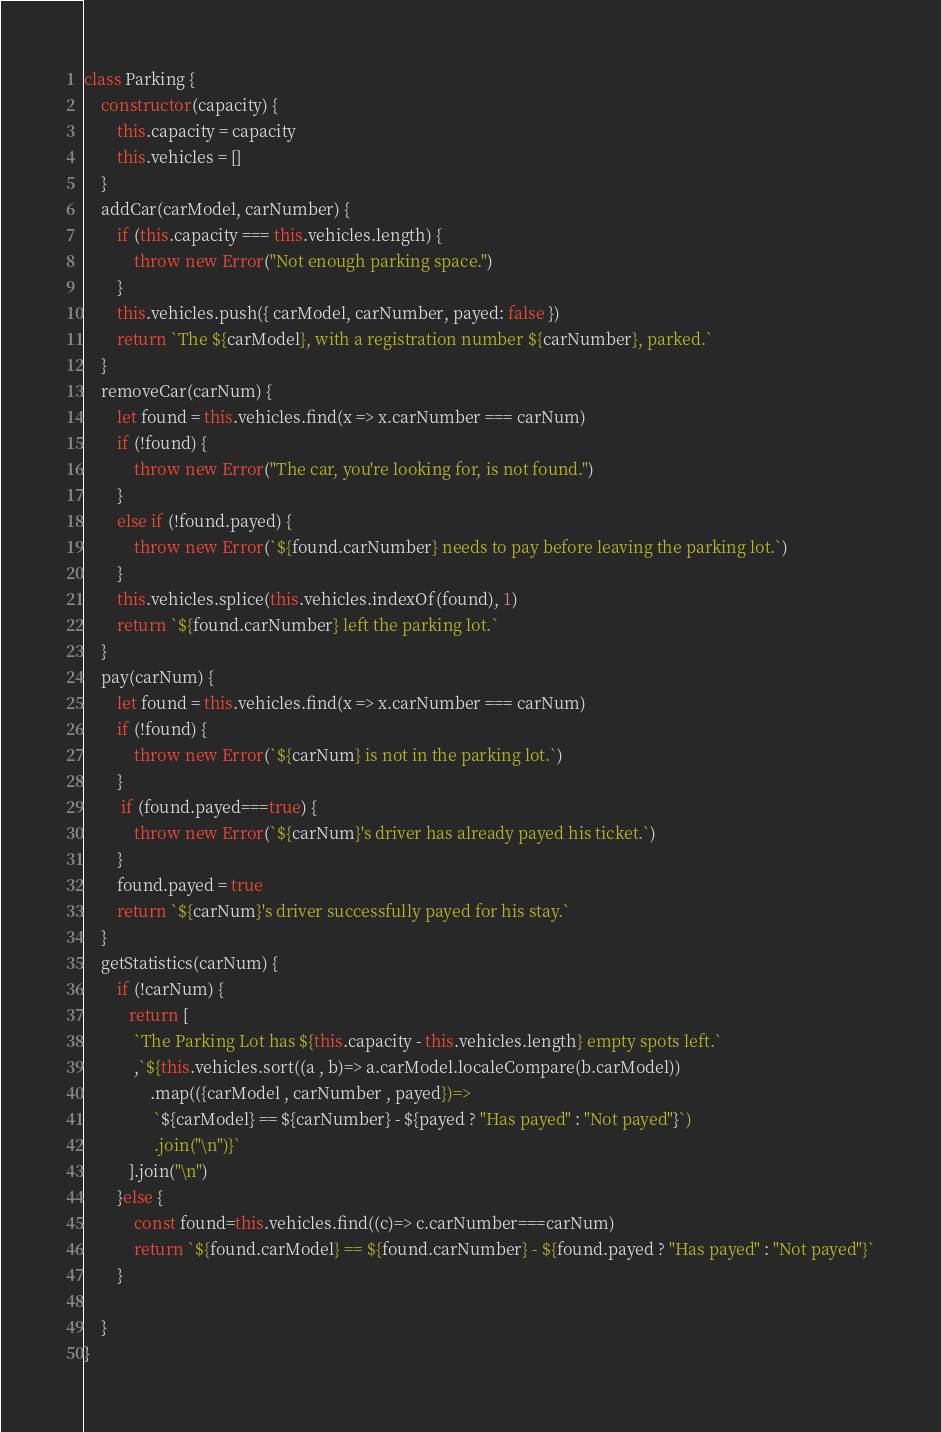Convert code to text. <code><loc_0><loc_0><loc_500><loc_500><_JavaScript_>class Parking {
    constructor(capacity) {
        this.capacity = capacity
        this.vehicles = []
    }
    addCar(carModel, carNumber) {
        if (this.capacity === this.vehicles.length) {
            throw new Error("Not enough parking space.")
        }
        this.vehicles.push({ carModel, carNumber, payed: false })
        return `The ${carModel}, with a registration number ${carNumber}, parked.`
    }
    removeCar(carNum) {
        let found = this.vehicles.find(x => x.carNumber === carNum)
        if (!found) {
            throw new Error("The car, you're looking for, is not found.")
        }
        else if (!found.payed) {
            throw new Error(`${found.carNumber} needs to pay before leaving the parking lot.`)
        }
        this.vehicles.splice(this.vehicles.indexOf(found), 1)
        return `${found.carNumber} left the parking lot.`
    }
    pay(carNum) {
        let found = this.vehicles.find(x => x.carNumber === carNum)
        if (!found) {
            throw new Error(`${carNum} is not in the parking lot.`)
        }
         if (found.payed===true) {
            throw new Error(`${carNum}'s driver has already payed his ticket.`)
        }
        found.payed = true
        return `${carNum}'s driver successfully payed for his stay.`
    }
    getStatistics(carNum) {
        if (!carNum) {
           return [
            `The Parking Lot has ${this.capacity - this.vehicles.length} empty spots left.`
            ,`${this.vehicles.sort((a , b)=> a.carModel.localeCompare(b.carModel))
                .map(({carModel , carNumber , payed})=>
                 `${carModel} == ${carNumber} - ${payed ? "Has payed" : "Not payed"}`)
                 .join("\n")}`
           ].join("\n")
        }else {
            const found=this.vehicles.find((c)=> c.carNumber===carNum)
            return `${found.carModel} == ${found.carNumber} - ${found.payed ? "Has payed" : "Not payed"}`
        }

    }
}
</code> 